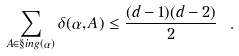Convert formula to latex. <formula><loc_0><loc_0><loc_500><loc_500>\sum _ { A \in \S i n g ( \alpha ) } \delta ( \alpha , A ) \leq \frac { ( d - 1 ) ( d - 2 ) } { 2 } \ .</formula> 